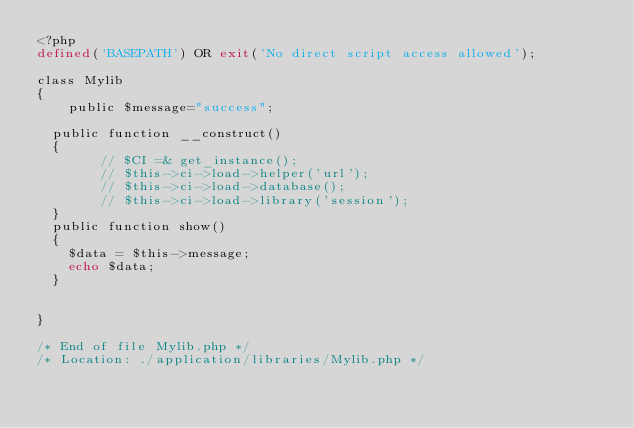Convert code to text. <code><loc_0><loc_0><loc_500><loc_500><_PHP_><?php
defined('BASEPATH') OR exit('No direct script access allowed');

class Mylib
{
		public $message="success";

	public function __construct()
	{
        // $CI =& get_instance();
        // $this->ci->load->helper('url');
        // $this->ci->load->database();
       	// $this->ci->load->library('session');
	}
	public function show()
	{
		$data = $this->message;
		echo $data;
	}
	

}

/* End of file Mylib.php */
/* Location: ./application/libraries/Mylib.php */
</code> 